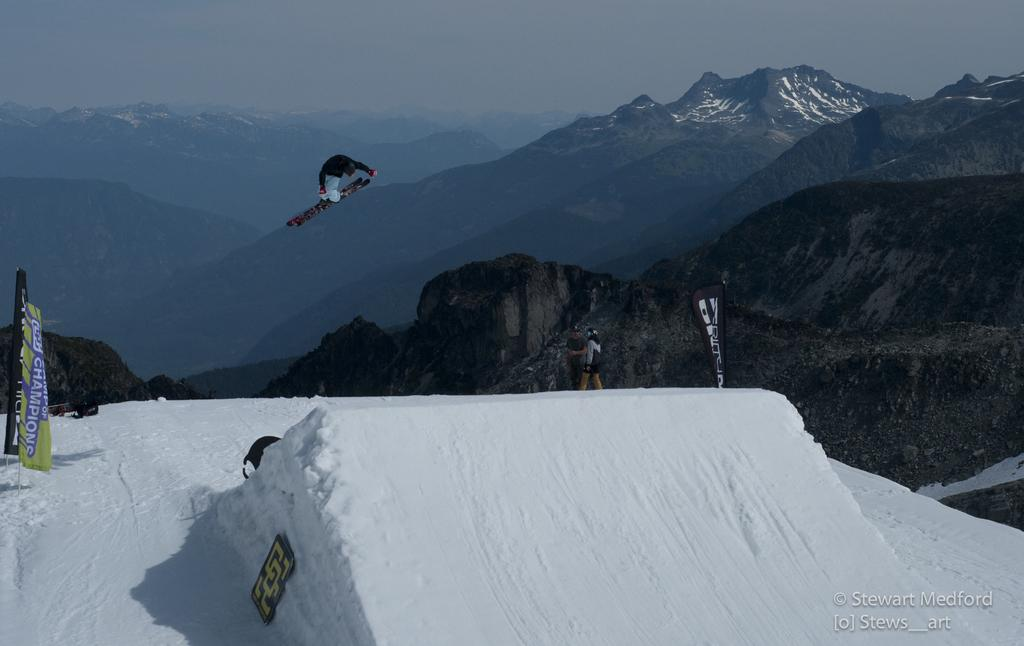What is the main subject of the image? There is a person in the image. What is the person doing in the image? The person is wearing skis and is in the air. What is the terrain like below the person? There is snow below the person. What can be seen on either side of the person? There are flags on either side of the person. What is visible in the background of the image? There are mountains in the background of the image. Where is the clam located in the image? There is no clam present in the image. What type of point is the person trying to make in the image? The image does not depict a situation where a point is being made; it shows a person skiing in the air. 